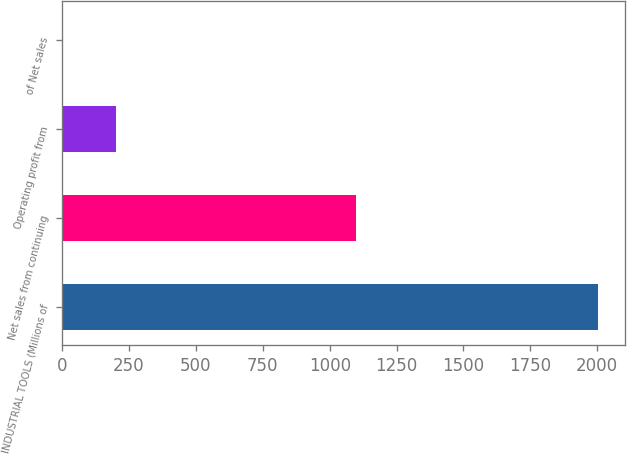Convert chart to OTSL. <chart><loc_0><loc_0><loc_500><loc_500><bar_chart><fcel>INDUSTRIAL TOOLS (Millions of<fcel>Net sales from continuing<fcel>Operating profit from<fcel>of Net sales<nl><fcel>2003<fcel>1098<fcel>201.65<fcel>1.5<nl></chart> 